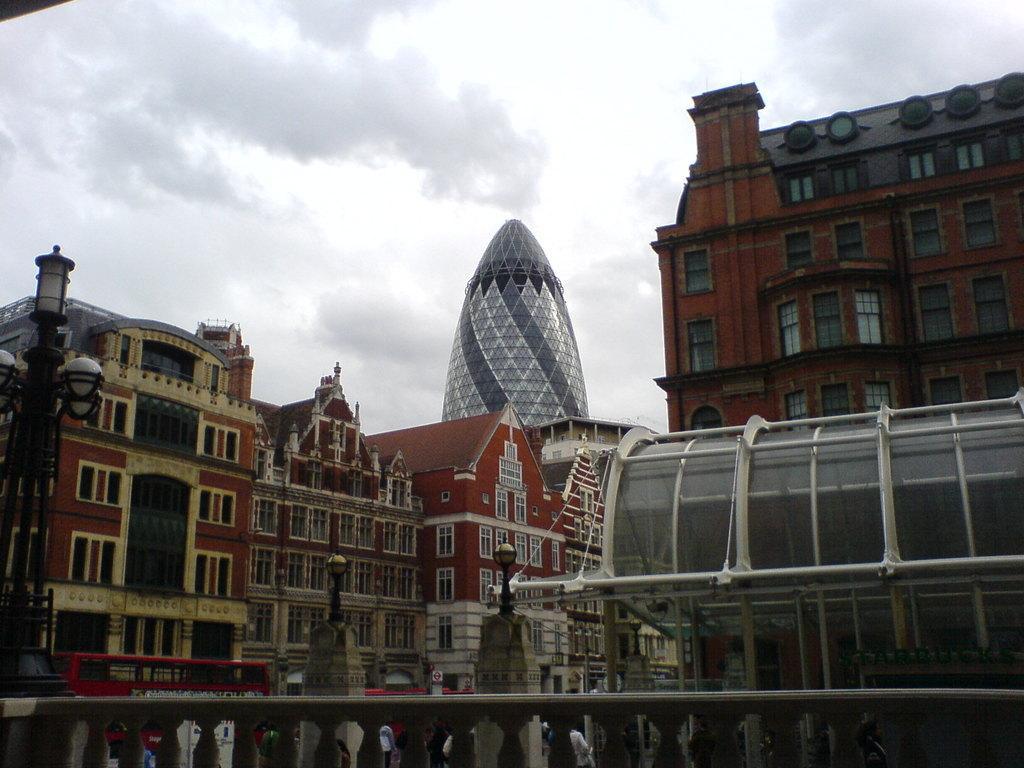How would you summarize this image in a sentence or two? In the foreground of the picture there is a bridge. On the left there are street lights. In the center of the picture there are vehicles and building. In the background there are buildings. Sky is cloudy. 